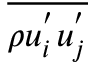Convert formula to latex. <formula><loc_0><loc_0><loc_500><loc_500>\overline { { \rho u _ { i } ^ { ^ { \prime } } u _ { j } ^ { ^ { \prime } } } }</formula> 